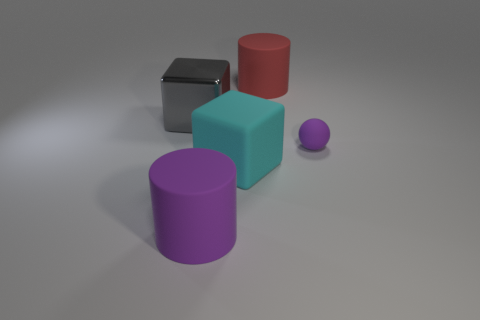Are there any other things that have the same shape as the tiny purple rubber thing?
Ensure brevity in your answer.  No. What size is the block that is made of the same material as the tiny purple object?
Your response must be concise. Large. Is the shape of the red thing the same as the big purple object?
Make the answer very short. Yes. There is another cylinder that is the same size as the purple cylinder; what is its color?
Your answer should be very brief. Red. The other rubber object that is the same shape as the big purple matte object is what size?
Keep it short and to the point. Large. The large matte thing on the left side of the big matte block has what shape?
Provide a succinct answer. Cylinder. There is a big red thing; does it have the same shape as the purple thing in front of the ball?
Give a very brief answer. Yes. Are there an equal number of red matte things that are in front of the small matte object and small spheres in front of the cyan cube?
Ensure brevity in your answer.  Yes. What is the shape of the object that is the same color as the ball?
Your answer should be compact. Cylinder. Does the large thing behind the big gray cube have the same color as the cube right of the shiny block?
Provide a short and direct response. No. 